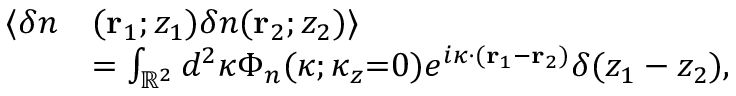Convert formula to latex. <formula><loc_0><loc_0><loc_500><loc_500>\begin{array} { r l } { \langle \delta n } & { ( r _ { 1 } ; z _ { 1 } ) \delta n ( r _ { 2 } ; z _ { 2 } ) \rangle } \\ & { = \int _ { \mathbb { R } ^ { 2 } } d ^ { 2 } \kappa \Phi _ { n } ( \kappa ; \kappa _ { z } { = } 0 ) e ^ { i \kappa \cdot ( r _ { 1 } - r _ { 2 } ) } \delta ( z _ { 1 } - z _ { 2 } ) , } \end{array}</formula> 